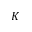<formula> <loc_0><loc_0><loc_500><loc_500>K</formula> 